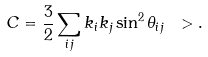Convert formula to latex. <formula><loc_0><loc_0><loc_500><loc_500>C = \frac { 3 } { 2 } \sum _ { i j } k _ { i } k _ { j } \sin ^ { 2 } \theta _ { i j } \ > .</formula> 